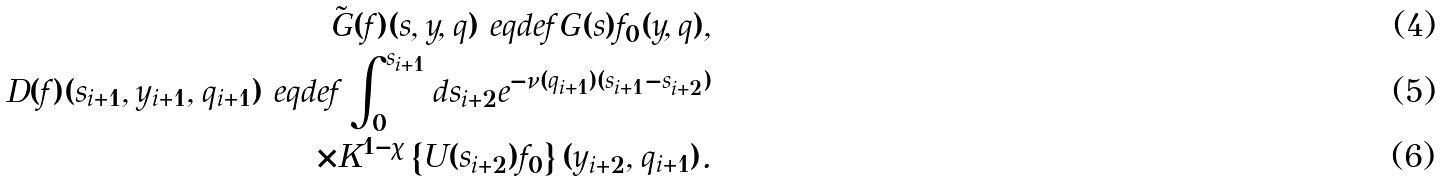Convert formula to latex. <formula><loc_0><loc_0><loc_500><loc_500>\tilde { G } ( f ) ( s , y , q ) \ e q d e f G ( s ) f _ { 0 } ( y , q ) , \\ D ( f ) ( s _ { i + 1 } , y _ { i + 1 } , q _ { i + 1 } ) \ e q d e f \int _ { 0 } ^ { s _ { i + 1 } } d s _ { i + 2 } e ^ { - \nu ( q _ { i + 1 } ) ( s _ { i + 1 } - s _ { i + 2 } ) } \\ \times K ^ { 1 - \chi } \left \{ U ( s _ { i + 2 } ) f _ { 0 } \right \} ( y _ { i + 2 } , q _ { i + 1 } ) .</formula> 